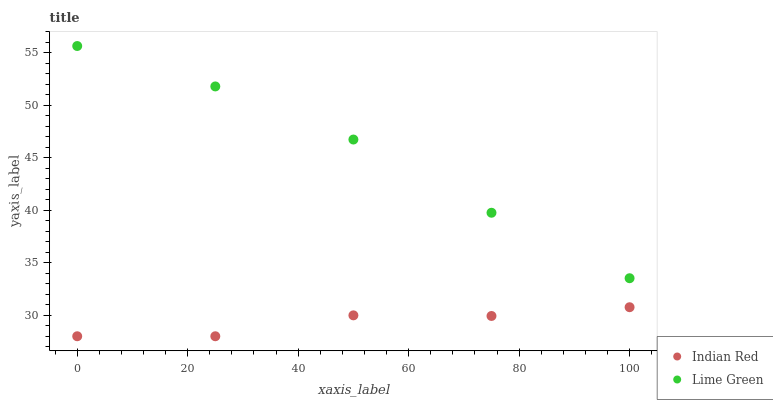Does Indian Red have the minimum area under the curve?
Answer yes or no. Yes. Does Lime Green have the maximum area under the curve?
Answer yes or no. Yes. Does Indian Red have the maximum area under the curve?
Answer yes or no. No. Is Lime Green the smoothest?
Answer yes or no. Yes. Is Indian Red the roughest?
Answer yes or no. Yes. Is Indian Red the smoothest?
Answer yes or no. No. Does Indian Red have the lowest value?
Answer yes or no. Yes. Does Lime Green have the highest value?
Answer yes or no. Yes. Does Indian Red have the highest value?
Answer yes or no. No. Is Indian Red less than Lime Green?
Answer yes or no. Yes. Is Lime Green greater than Indian Red?
Answer yes or no. Yes. Does Indian Red intersect Lime Green?
Answer yes or no. No. 